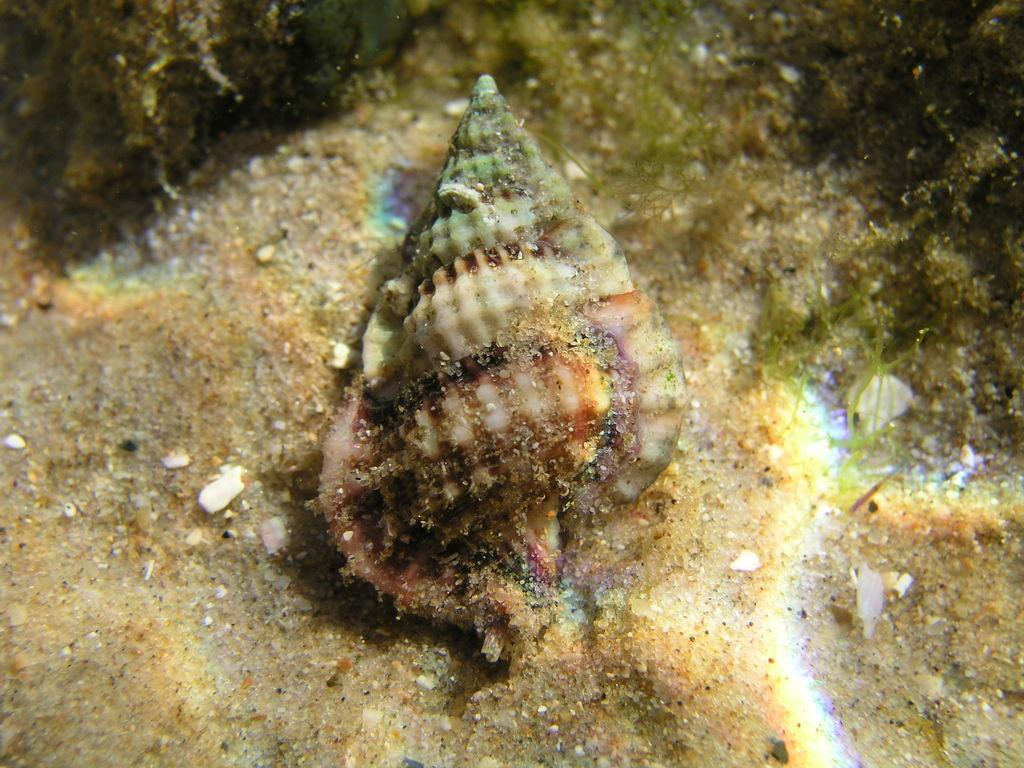What is the main object in the image? There is a seashell in the image. What else can be seen at the bottom of the image? There are stones at the bottom of the image. Can you describe the environment depicted in the image? The image depicts an underwater environment. Where is the mother in the image? There is no mother present in the image; it depicts an underwater environment with a seashell and stones. How many horses can be seen in the image? There are no horses present in the image; it depicts an underwater environment with a seashell and stones. 